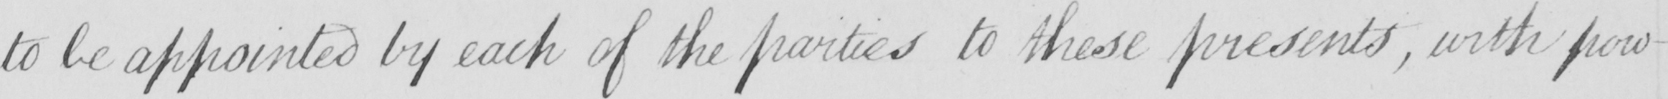Please transcribe the handwritten text in this image. to be appointed by each of the parties to these presents , with pow- 